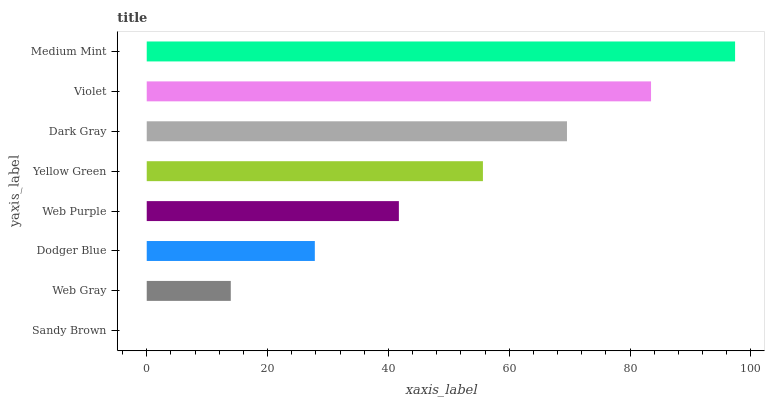Is Sandy Brown the minimum?
Answer yes or no. Yes. Is Medium Mint the maximum?
Answer yes or no. Yes. Is Web Gray the minimum?
Answer yes or no. No. Is Web Gray the maximum?
Answer yes or no. No. Is Web Gray greater than Sandy Brown?
Answer yes or no. Yes. Is Sandy Brown less than Web Gray?
Answer yes or no. Yes. Is Sandy Brown greater than Web Gray?
Answer yes or no. No. Is Web Gray less than Sandy Brown?
Answer yes or no. No. Is Yellow Green the high median?
Answer yes or no. Yes. Is Web Purple the low median?
Answer yes or no. Yes. Is Web Gray the high median?
Answer yes or no. No. Is Violet the low median?
Answer yes or no. No. 